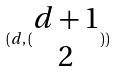Convert formula to latex. <formula><loc_0><loc_0><loc_500><loc_500>( d , ( \begin{matrix} d + 1 \\ 2 \end{matrix} ) )</formula> 